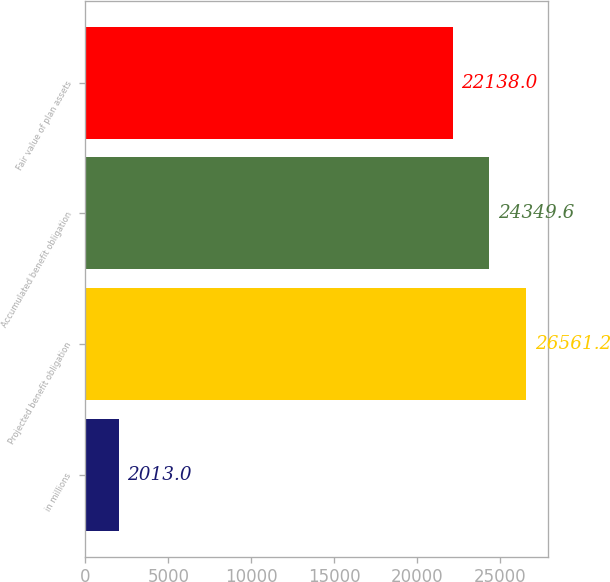<chart> <loc_0><loc_0><loc_500><loc_500><bar_chart><fcel>in millions<fcel>Projected benefit obligation<fcel>Accumulated benefit obligation<fcel>Fair value of plan assets<nl><fcel>2013<fcel>26561.2<fcel>24349.6<fcel>22138<nl></chart> 